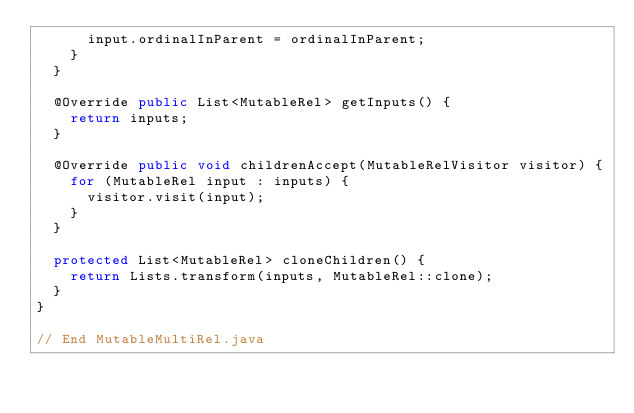Convert code to text. <code><loc_0><loc_0><loc_500><loc_500><_Java_>      input.ordinalInParent = ordinalInParent;
    }
  }

  @Override public List<MutableRel> getInputs() {
    return inputs;
  }

  @Override public void childrenAccept(MutableRelVisitor visitor) {
    for (MutableRel input : inputs) {
      visitor.visit(input);
    }
  }

  protected List<MutableRel> cloneChildren() {
    return Lists.transform(inputs, MutableRel::clone);
  }
}

// End MutableMultiRel.java
</code> 